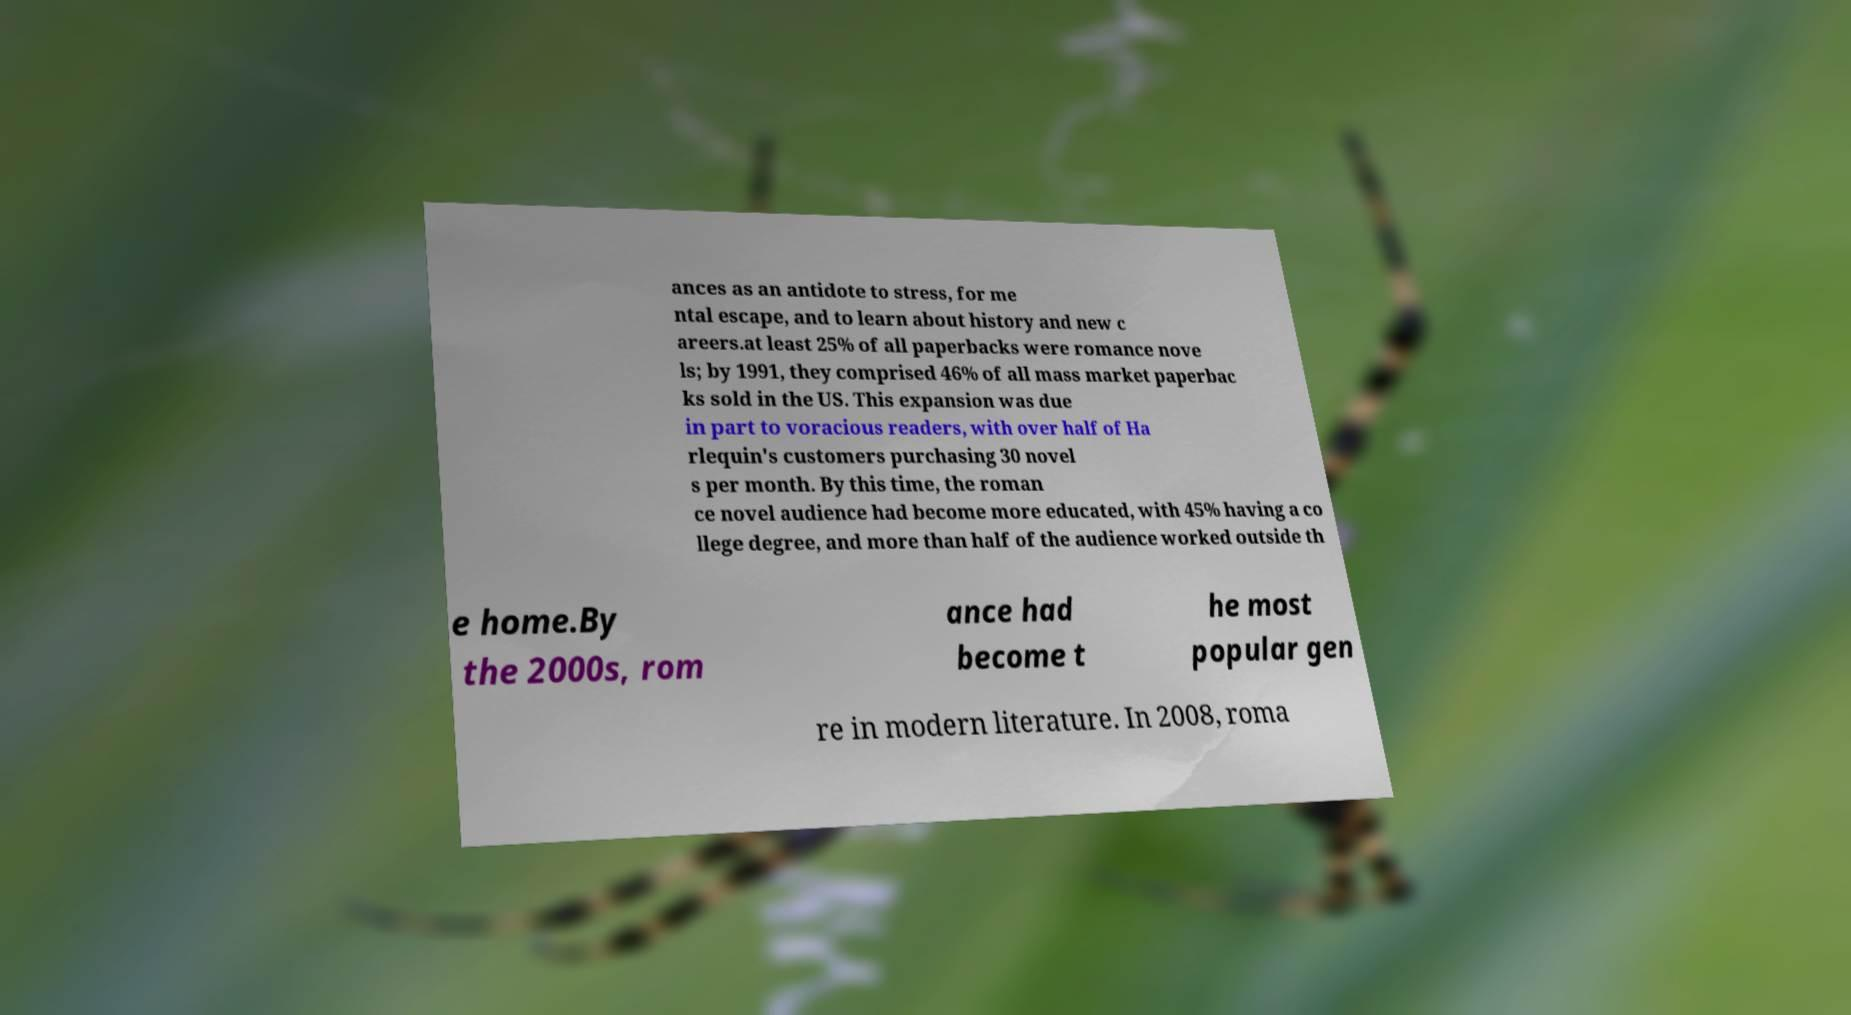There's text embedded in this image that I need extracted. Can you transcribe it verbatim? ances as an antidote to stress, for me ntal escape, and to learn about history and new c areers.at least 25% of all paperbacks were romance nove ls; by 1991, they comprised 46% of all mass market paperbac ks sold in the US. This expansion was due in part to voracious readers, with over half of Ha rlequin's customers purchasing 30 novel s per month. By this time, the roman ce novel audience had become more educated, with 45% having a co llege degree, and more than half of the audience worked outside th e home.By the 2000s, rom ance had become t he most popular gen re in modern literature. In 2008, roma 